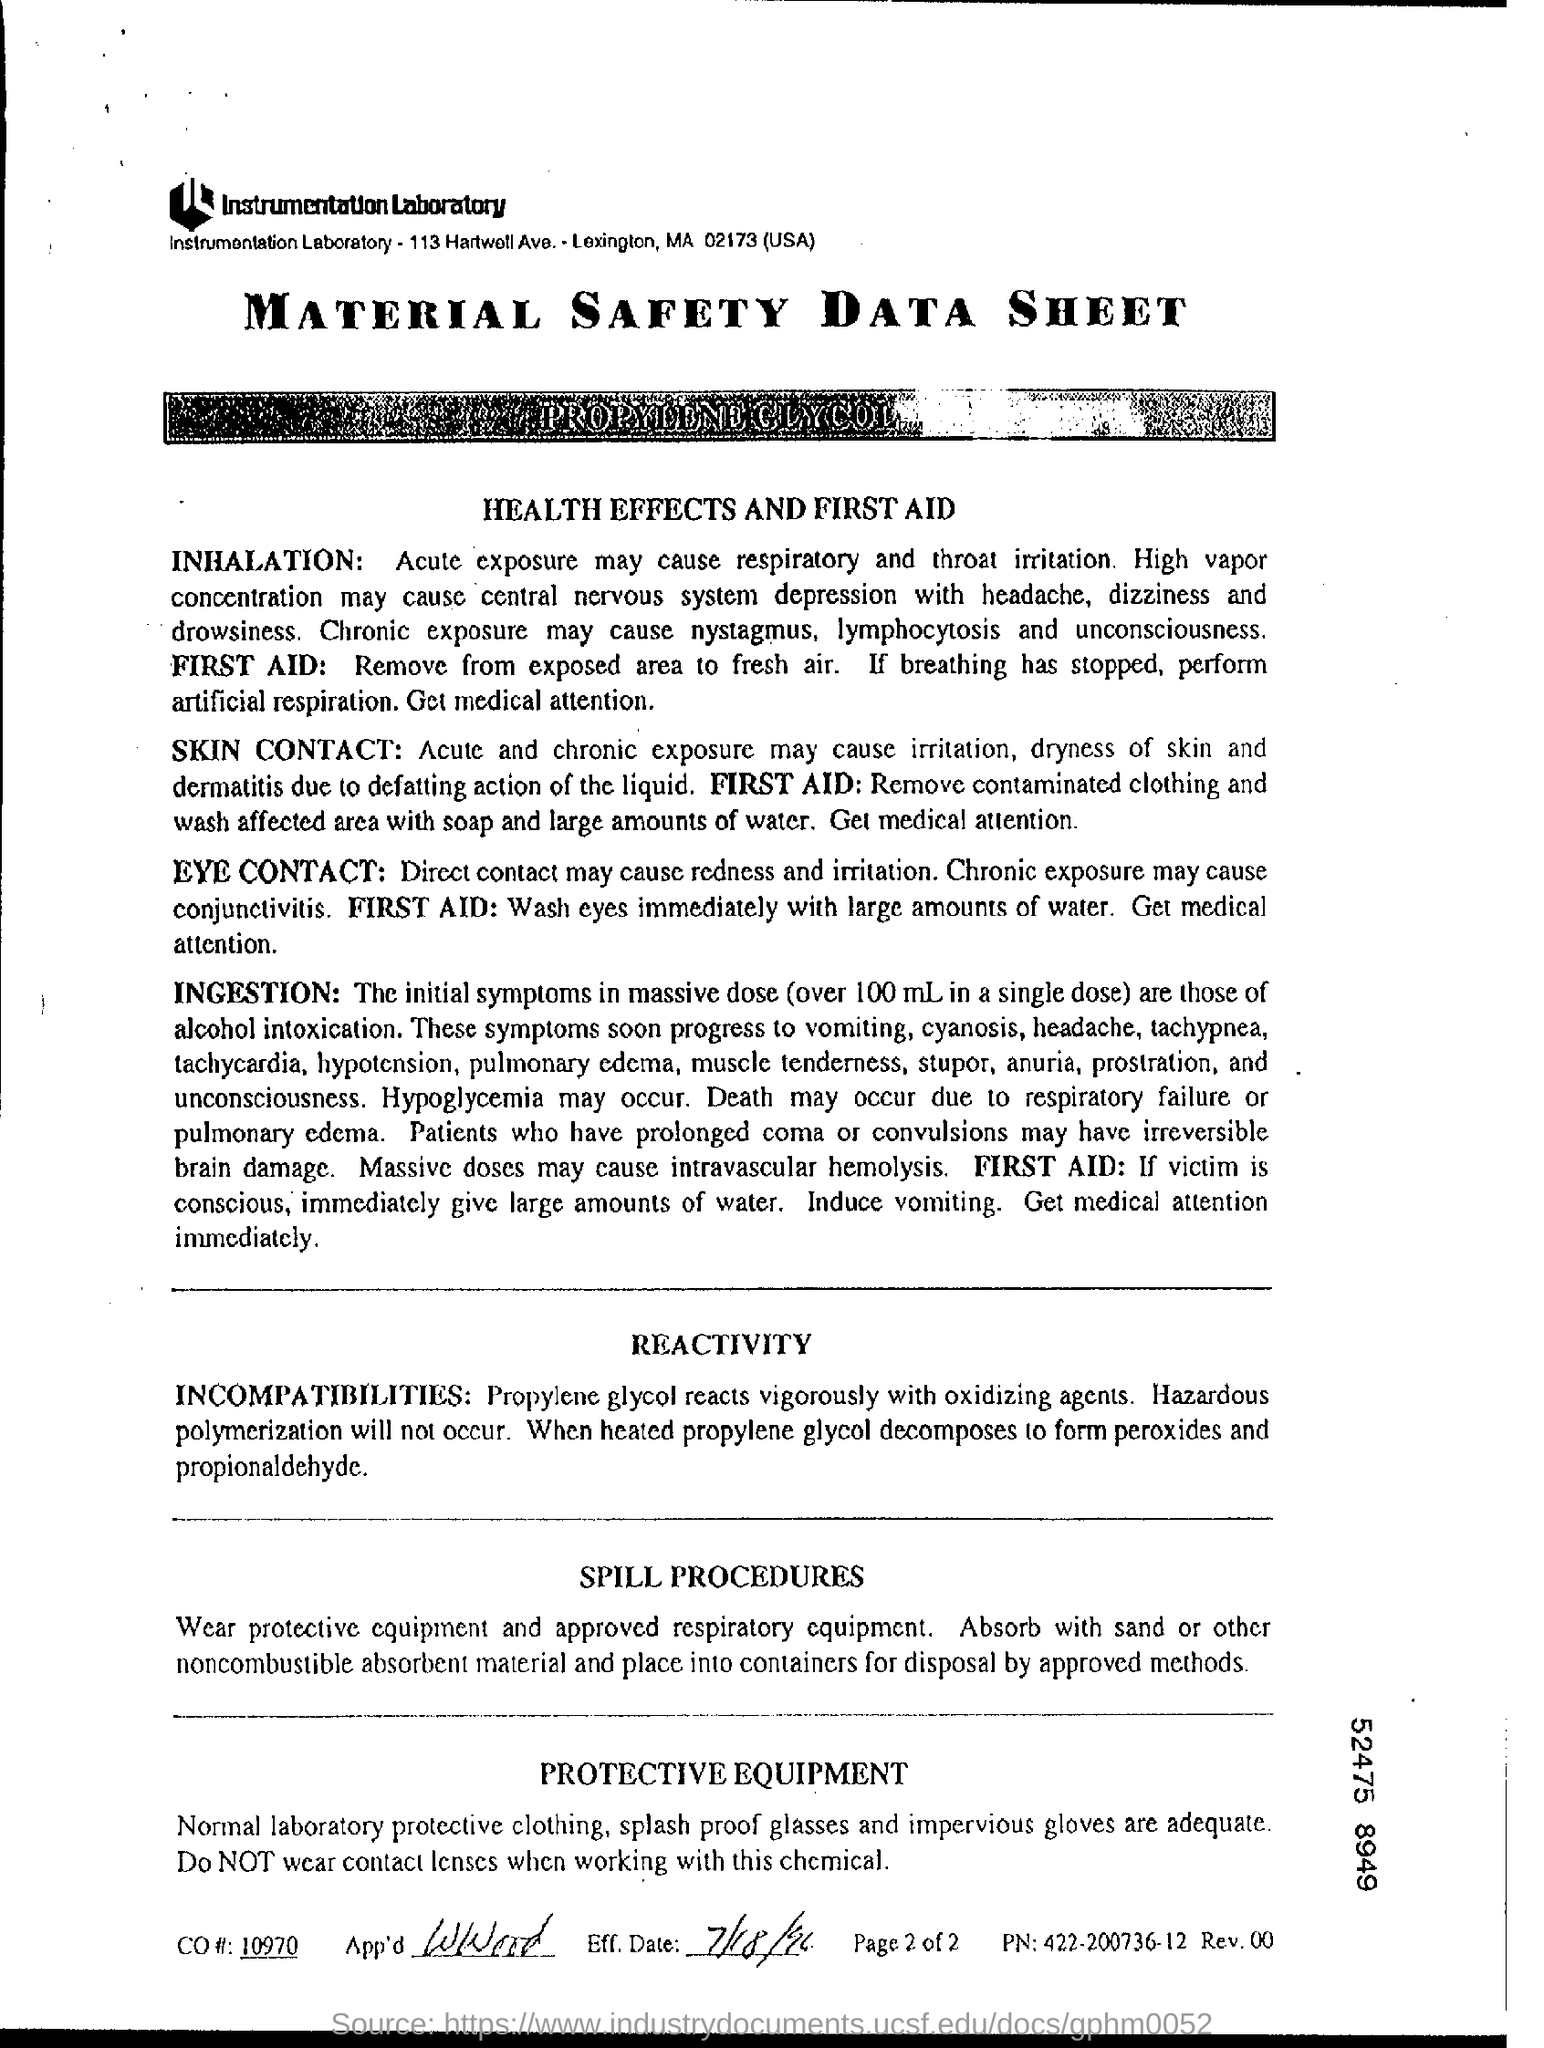What is the Title of the Document?
Your answer should be very brief. Material Safety Data Sheet. What is the CO #?
Provide a short and direct response. 10970. What is the Eff. Date?
Make the answer very short. 7/18/96. What is PN?
Keep it short and to the point. 422-200736-12. 